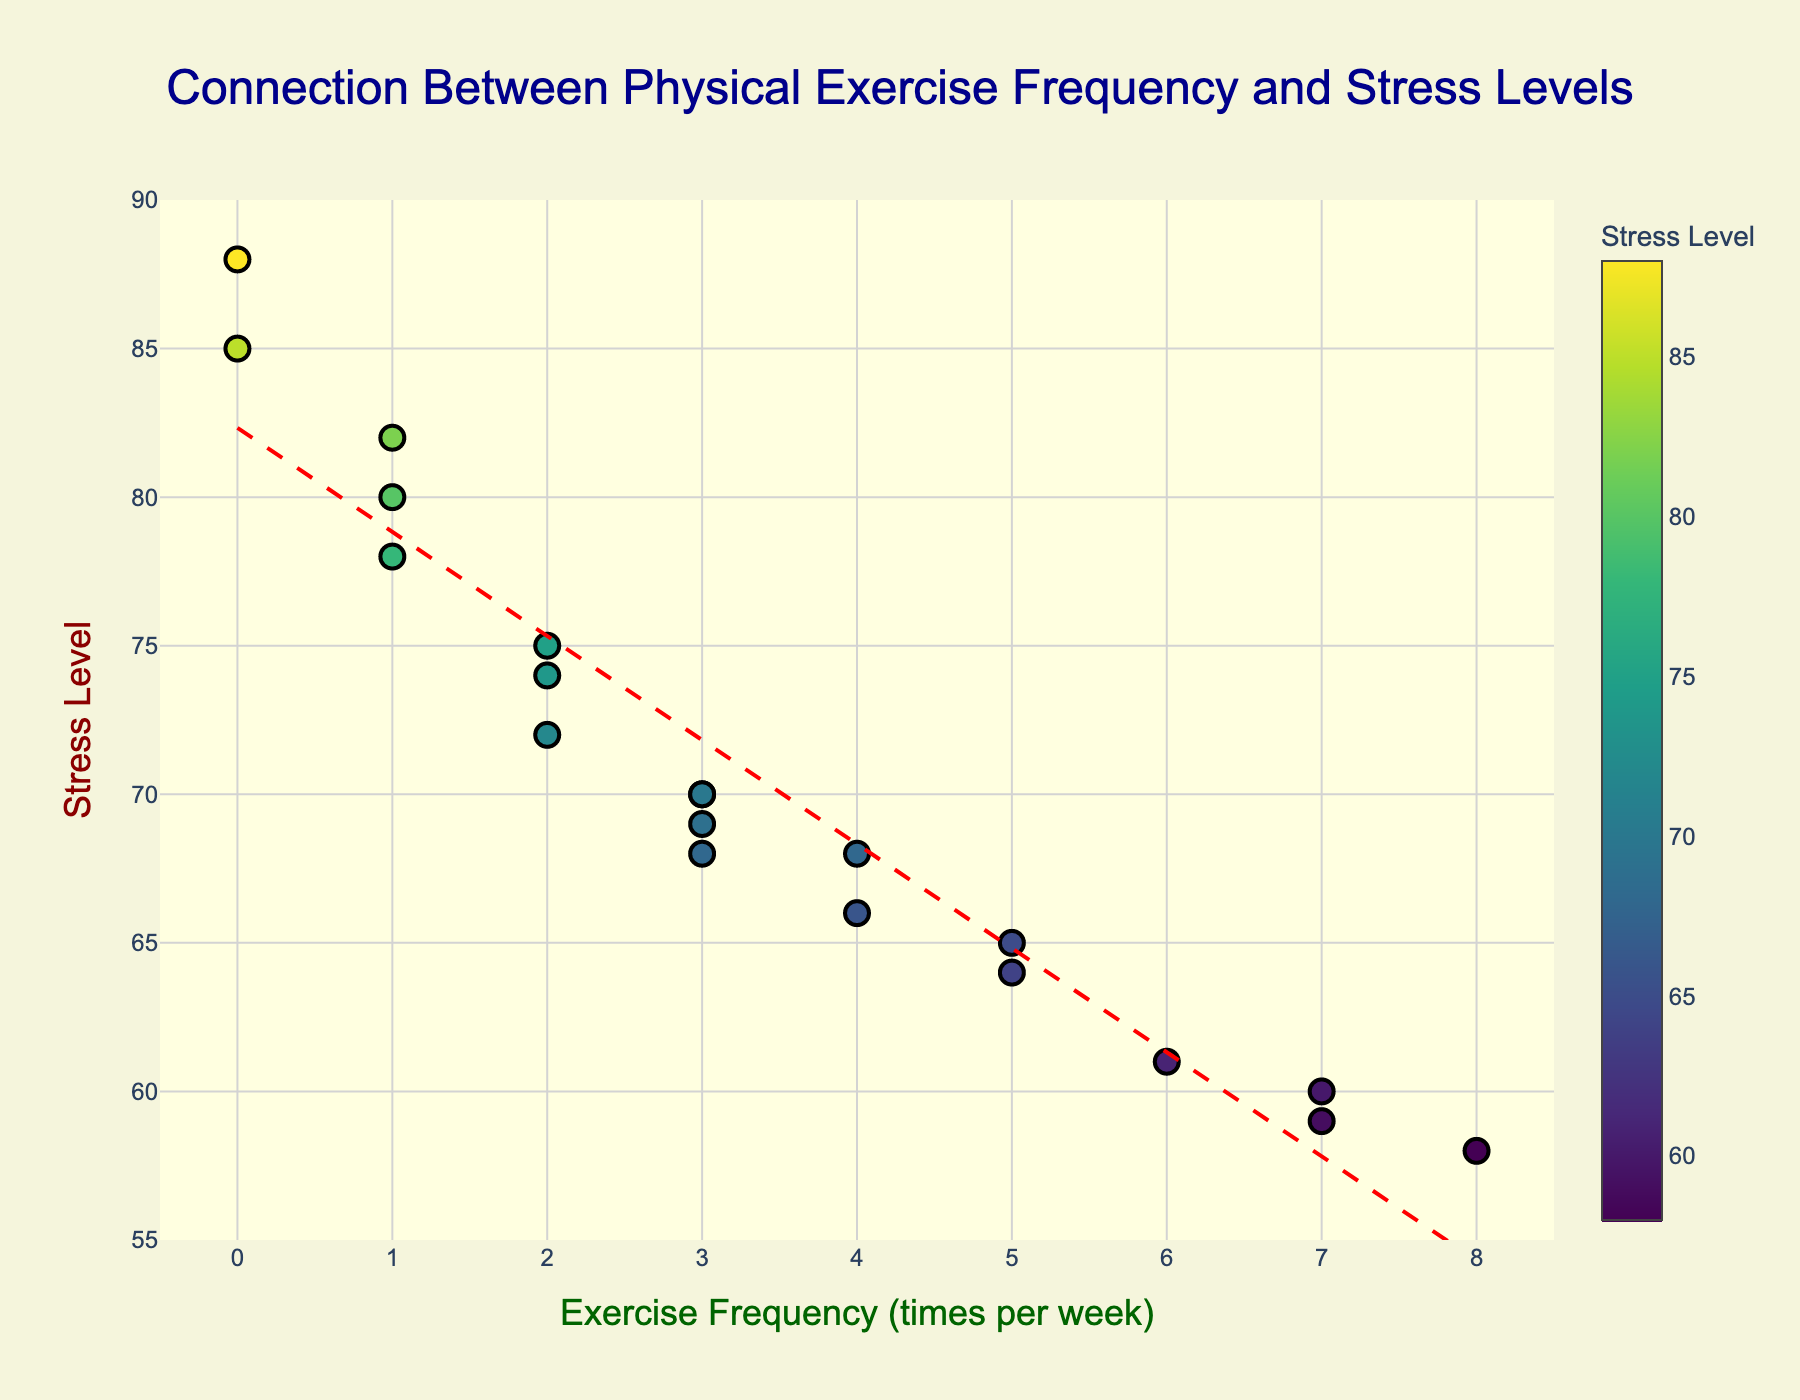What is the title of the scatter plot? The title of the scatter plot is positioned at the top center of the chart, and it summarizes the main topic or relationship being displayed in the plot.
Answer: Connection Between Physical Exercise Frequency and Stress Levels What are the labels for the x-axis and y-axis? The labels for the axes describe what each axis represents, with the x-axis indicating the independent variable and the y-axis indicating the dependent variable.
Answer: Exercise Frequency (times per week), Stress Level How many data points are shown in the scatter plot? By visually counting the number of markers (points) on the scatter plot, we can determine the total number of data points.
Answer: 20 How does the trend line generally slope? Observing the trend line on the scatter plot reveals its direction; whether it increases, decreases, or remains constant.
Answer: Downward At which frequency of exercise do we see the lowest stress level? By identifying the point on the x-axis with the lowest corresponding y-value (stress level), we can determine this frequency.
Answer: 8 times per week What is the stress level for the data point where exercise frequency is 6 times per week? Look for the marker that aligns with an x-value of 6 and note the corresponding y-value.
Answer: 61 Does an increase in exercise frequency generally correlate with an increase or decrease in stress levels? Examining the general trend indicated by the markers and the trend line helps determine the nature of the correlation between the two variables.
Answer: Decrease Which exercise frequency has the most varied stress level, and what are those levels? Identify the exercise frequency with multiple data points having different stress levels and note those stress values.
Answer: 3 times per week, with stress levels of 70, 68, 69, 70 On average, how much does the stress level decrease per additional exercise session? Calculate the slope of the trend line (found using the line formula from polyfit), which represents the average decrease in stress level per additional exercise session. The slope can be approximated visually by noting the rate of the decline in the fitted line.
Answer: Approximately 3.22 What is the range of stress levels observed in individuals who exercise between 1 and 4 times per week? Find the minimum and maximum stress levels for exercise frequencies from 1 to 4 times per week and subtract the minimum from the maximum to determine the range.
Answer: Range is 66 to 82, thus 16 